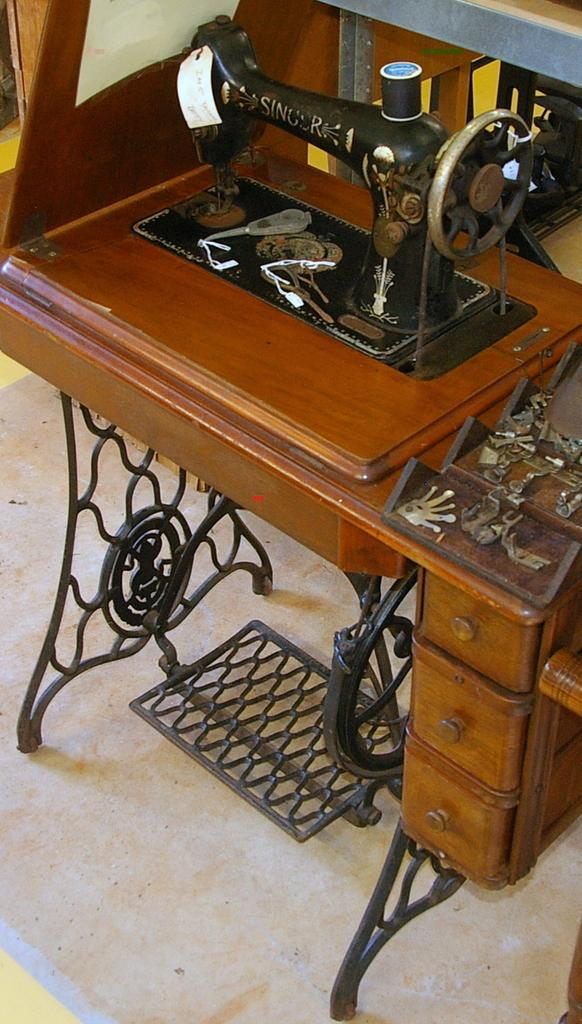What is placed on the floor in the image? There is a sewing machine placed on the floor. Is the sewing machine accompanied by any other objects or figures? The image only shows a sewing machine placed on the floor. What type of butter is the sewing machine using to sew in the image? There is no butter present in the image, and sewing machines do not use butter for sewing. 